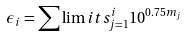Convert formula to latex. <formula><loc_0><loc_0><loc_500><loc_500>\epsilon _ { i } = \sum \lim i t s _ { j = 1 } ^ { i } 1 0 ^ { 0 . 7 5 m _ { j } }</formula> 